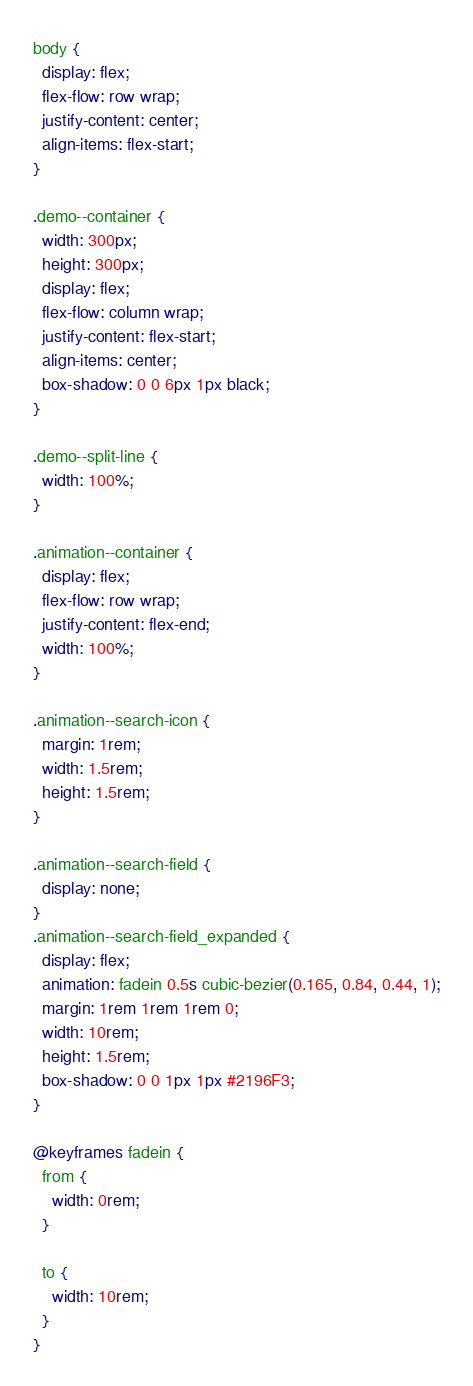<code> <loc_0><loc_0><loc_500><loc_500><_CSS_>body {
  display: flex;
  flex-flow: row wrap;
  justify-content: center;
  align-items: flex-start;
}

.demo--container {
  width: 300px;
  height: 300px;
  display: flex;
  flex-flow: column wrap;
  justify-content: flex-start;
  align-items: center;
  box-shadow: 0 0 6px 1px black;
}

.demo--split-line {
  width: 100%;
}

.animation--container {
  display: flex;
  flex-flow: row wrap;
  justify-content: flex-end;
  width: 100%;
}

.animation--search-icon {
  margin: 1rem;
  width: 1.5rem;
  height: 1.5rem;
}

.animation--search-field {
  display: none;
}
.animation--search-field_expanded {
  display: flex;
  animation: fadein 0.5s cubic-bezier(0.165, 0.84, 0.44, 1);
  margin: 1rem 1rem 1rem 0;
  width: 10rem;
  height: 1.5rem;
  box-shadow: 0 0 1px 1px #2196F3;
}

@keyframes fadein {
  from {
    width: 0rem;
  }

  to {
    width: 10rem;
  }
}
</code> 